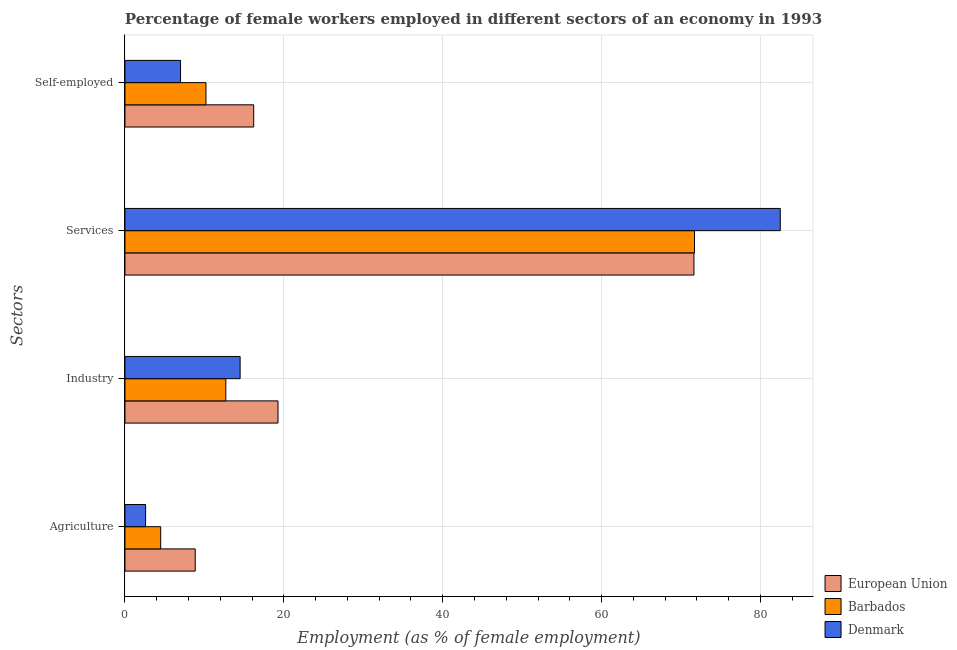Are the number of bars on each tick of the Y-axis equal?
Offer a terse response. Yes. How many bars are there on the 1st tick from the bottom?
Give a very brief answer. 3. What is the label of the 3rd group of bars from the top?
Offer a terse response. Industry. What is the percentage of female workers in agriculture in Denmark?
Provide a short and direct response. 2.6. Across all countries, what is the maximum percentage of self employed female workers?
Offer a terse response. 16.21. Across all countries, what is the minimum percentage of female workers in agriculture?
Offer a very short reply. 2.6. In which country was the percentage of female workers in industry minimum?
Keep it short and to the point. Barbados. What is the total percentage of female workers in services in the graph?
Ensure brevity in your answer.  225.83. What is the difference between the percentage of self employed female workers in Barbados and that in Denmark?
Your answer should be very brief. 3.2. What is the difference between the percentage of female workers in agriculture in Barbados and the percentage of self employed female workers in European Union?
Give a very brief answer. -11.71. What is the average percentage of self employed female workers per country?
Ensure brevity in your answer.  11.14. In how many countries, is the percentage of self employed female workers greater than 12 %?
Offer a very short reply. 1. What is the ratio of the percentage of female workers in agriculture in European Union to that in Barbados?
Give a very brief answer. 1.97. Is the percentage of self employed female workers in European Union less than that in Denmark?
Offer a terse response. No. Is the difference between the percentage of female workers in industry in Barbados and Denmark greater than the difference between the percentage of self employed female workers in Barbados and Denmark?
Your answer should be very brief. No. What is the difference between the highest and the second highest percentage of female workers in industry?
Make the answer very short. 4.77. What is the difference between the highest and the lowest percentage of female workers in agriculture?
Offer a terse response. 6.25. Is the sum of the percentage of female workers in agriculture in Denmark and Barbados greater than the maximum percentage of female workers in industry across all countries?
Provide a succinct answer. No. Is it the case that in every country, the sum of the percentage of self employed female workers and percentage of female workers in agriculture is greater than the sum of percentage of female workers in services and percentage of female workers in industry?
Provide a short and direct response. No. What does the 2nd bar from the bottom in Self-employed represents?
Your answer should be very brief. Barbados. How many countries are there in the graph?
Give a very brief answer. 3. Are the values on the major ticks of X-axis written in scientific E-notation?
Keep it short and to the point. No. Does the graph contain grids?
Your response must be concise. Yes. Where does the legend appear in the graph?
Your answer should be compact. Bottom right. How many legend labels are there?
Your answer should be very brief. 3. How are the legend labels stacked?
Your answer should be compact. Vertical. What is the title of the graph?
Make the answer very short. Percentage of female workers employed in different sectors of an economy in 1993. Does "Netherlands" appear as one of the legend labels in the graph?
Keep it short and to the point. No. What is the label or title of the X-axis?
Keep it short and to the point. Employment (as % of female employment). What is the label or title of the Y-axis?
Give a very brief answer. Sectors. What is the Employment (as % of female employment) in European Union in Agriculture?
Your answer should be compact. 8.85. What is the Employment (as % of female employment) in Denmark in Agriculture?
Keep it short and to the point. 2.6. What is the Employment (as % of female employment) of European Union in Industry?
Your response must be concise. 19.27. What is the Employment (as % of female employment) in Barbados in Industry?
Make the answer very short. 12.7. What is the Employment (as % of female employment) in Denmark in Industry?
Ensure brevity in your answer.  14.5. What is the Employment (as % of female employment) in European Union in Services?
Provide a succinct answer. 71.63. What is the Employment (as % of female employment) in Barbados in Services?
Give a very brief answer. 71.7. What is the Employment (as % of female employment) in Denmark in Services?
Your answer should be compact. 82.5. What is the Employment (as % of female employment) of European Union in Self-employed?
Your answer should be compact. 16.21. What is the Employment (as % of female employment) in Barbados in Self-employed?
Provide a short and direct response. 10.2. Across all Sectors, what is the maximum Employment (as % of female employment) of European Union?
Keep it short and to the point. 71.63. Across all Sectors, what is the maximum Employment (as % of female employment) of Barbados?
Your answer should be very brief. 71.7. Across all Sectors, what is the maximum Employment (as % of female employment) of Denmark?
Give a very brief answer. 82.5. Across all Sectors, what is the minimum Employment (as % of female employment) in European Union?
Your answer should be very brief. 8.85. Across all Sectors, what is the minimum Employment (as % of female employment) of Barbados?
Provide a short and direct response. 4.5. Across all Sectors, what is the minimum Employment (as % of female employment) of Denmark?
Offer a very short reply. 2.6. What is the total Employment (as % of female employment) in European Union in the graph?
Offer a terse response. 115.96. What is the total Employment (as % of female employment) of Barbados in the graph?
Provide a succinct answer. 99.1. What is the total Employment (as % of female employment) in Denmark in the graph?
Offer a very short reply. 106.6. What is the difference between the Employment (as % of female employment) of European Union in Agriculture and that in Industry?
Ensure brevity in your answer.  -10.42. What is the difference between the Employment (as % of female employment) of Denmark in Agriculture and that in Industry?
Provide a short and direct response. -11.9. What is the difference between the Employment (as % of female employment) in European Union in Agriculture and that in Services?
Make the answer very short. -62.78. What is the difference between the Employment (as % of female employment) in Barbados in Agriculture and that in Services?
Your response must be concise. -67.2. What is the difference between the Employment (as % of female employment) in Denmark in Agriculture and that in Services?
Make the answer very short. -79.9. What is the difference between the Employment (as % of female employment) of European Union in Agriculture and that in Self-employed?
Ensure brevity in your answer.  -7.36. What is the difference between the Employment (as % of female employment) in Barbados in Agriculture and that in Self-employed?
Offer a very short reply. -5.7. What is the difference between the Employment (as % of female employment) in European Union in Industry and that in Services?
Keep it short and to the point. -52.36. What is the difference between the Employment (as % of female employment) of Barbados in Industry and that in Services?
Your answer should be compact. -59. What is the difference between the Employment (as % of female employment) of Denmark in Industry and that in Services?
Provide a short and direct response. -68. What is the difference between the Employment (as % of female employment) of European Union in Industry and that in Self-employed?
Offer a terse response. 3.06. What is the difference between the Employment (as % of female employment) in Denmark in Industry and that in Self-employed?
Provide a short and direct response. 7.5. What is the difference between the Employment (as % of female employment) in European Union in Services and that in Self-employed?
Your response must be concise. 55.42. What is the difference between the Employment (as % of female employment) of Barbados in Services and that in Self-employed?
Keep it short and to the point. 61.5. What is the difference between the Employment (as % of female employment) in Denmark in Services and that in Self-employed?
Your answer should be compact. 75.5. What is the difference between the Employment (as % of female employment) of European Union in Agriculture and the Employment (as % of female employment) of Barbados in Industry?
Your response must be concise. -3.85. What is the difference between the Employment (as % of female employment) in European Union in Agriculture and the Employment (as % of female employment) in Denmark in Industry?
Offer a very short reply. -5.65. What is the difference between the Employment (as % of female employment) of European Union in Agriculture and the Employment (as % of female employment) of Barbados in Services?
Make the answer very short. -62.85. What is the difference between the Employment (as % of female employment) in European Union in Agriculture and the Employment (as % of female employment) in Denmark in Services?
Your answer should be compact. -73.65. What is the difference between the Employment (as % of female employment) in Barbados in Agriculture and the Employment (as % of female employment) in Denmark in Services?
Ensure brevity in your answer.  -78. What is the difference between the Employment (as % of female employment) in European Union in Agriculture and the Employment (as % of female employment) in Barbados in Self-employed?
Make the answer very short. -1.35. What is the difference between the Employment (as % of female employment) in European Union in Agriculture and the Employment (as % of female employment) in Denmark in Self-employed?
Make the answer very short. 1.85. What is the difference between the Employment (as % of female employment) of European Union in Industry and the Employment (as % of female employment) of Barbados in Services?
Make the answer very short. -52.43. What is the difference between the Employment (as % of female employment) of European Union in Industry and the Employment (as % of female employment) of Denmark in Services?
Give a very brief answer. -63.23. What is the difference between the Employment (as % of female employment) of Barbados in Industry and the Employment (as % of female employment) of Denmark in Services?
Keep it short and to the point. -69.8. What is the difference between the Employment (as % of female employment) of European Union in Industry and the Employment (as % of female employment) of Barbados in Self-employed?
Make the answer very short. 9.07. What is the difference between the Employment (as % of female employment) in European Union in Industry and the Employment (as % of female employment) in Denmark in Self-employed?
Ensure brevity in your answer.  12.27. What is the difference between the Employment (as % of female employment) of European Union in Services and the Employment (as % of female employment) of Barbados in Self-employed?
Your answer should be very brief. 61.43. What is the difference between the Employment (as % of female employment) in European Union in Services and the Employment (as % of female employment) in Denmark in Self-employed?
Offer a very short reply. 64.63. What is the difference between the Employment (as % of female employment) in Barbados in Services and the Employment (as % of female employment) in Denmark in Self-employed?
Offer a terse response. 64.7. What is the average Employment (as % of female employment) of European Union per Sectors?
Your response must be concise. 28.99. What is the average Employment (as % of female employment) in Barbados per Sectors?
Provide a succinct answer. 24.77. What is the average Employment (as % of female employment) in Denmark per Sectors?
Make the answer very short. 26.65. What is the difference between the Employment (as % of female employment) in European Union and Employment (as % of female employment) in Barbados in Agriculture?
Your response must be concise. 4.35. What is the difference between the Employment (as % of female employment) in European Union and Employment (as % of female employment) in Denmark in Agriculture?
Offer a very short reply. 6.25. What is the difference between the Employment (as % of female employment) of European Union and Employment (as % of female employment) of Barbados in Industry?
Give a very brief answer. 6.57. What is the difference between the Employment (as % of female employment) in European Union and Employment (as % of female employment) in Denmark in Industry?
Ensure brevity in your answer.  4.77. What is the difference between the Employment (as % of female employment) of Barbados and Employment (as % of female employment) of Denmark in Industry?
Give a very brief answer. -1.8. What is the difference between the Employment (as % of female employment) in European Union and Employment (as % of female employment) in Barbados in Services?
Your response must be concise. -0.07. What is the difference between the Employment (as % of female employment) in European Union and Employment (as % of female employment) in Denmark in Services?
Your answer should be compact. -10.87. What is the difference between the Employment (as % of female employment) in Barbados and Employment (as % of female employment) in Denmark in Services?
Your answer should be compact. -10.8. What is the difference between the Employment (as % of female employment) of European Union and Employment (as % of female employment) of Barbados in Self-employed?
Your answer should be compact. 6.01. What is the difference between the Employment (as % of female employment) of European Union and Employment (as % of female employment) of Denmark in Self-employed?
Your answer should be very brief. 9.21. What is the difference between the Employment (as % of female employment) in Barbados and Employment (as % of female employment) in Denmark in Self-employed?
Offer a terse response. 3.2. What is the ratio of the Employment (as % of female employment) in European Union in Agriculture to that in Industry?
Your answer should be compact. 0.46. What is the ratio of the Employment (as % of female employment) in Barbados in Agriculture to that in Industry?
Provide a short and direct response. 0.35. What is the ratio of the Employment (as % of female employment) of Denmark in Agriculture to that in Industry?
Offer a very short reply. 0.18. What is the ratio of the Employment (as % of female employment) in European Union in Agriculture to that in Services?
Offer a very short reply. 0.12. What is the ratio of the Employment (as % of female employment) of Barbados in Agriculture to that in Services?
Offer a very short reply. 0.06. What is the ratio of the Employment (as % of female employment) in Denmark in Agriculture to that in Services?
Your answer should be compact. 0.03. What is the ratio of the Employment (as % of female employment) of European Union in Agriculture to that in Self-employed?
Offer a very short reply. 0.55. What is the ratio of the Employment (as % of female employment) of Barbados in Agriculture to that in Self-employed?
Make the answer very short. 0.44. What is the ratio of the Employment (as % of female employment) in Denmark in Agriculture to that in Self-employed?
Your answer should be very brief. 0.37. What is the ratio of the Employment (as % of female employment) in European Union in Industry to that in Services?
Keep it short and to the point. 0.27. What is the ratio of the Employment (as % of female employment) of Barbados in Industry to that in Services?
Your answer should be compact. 0.18. What is the ratio of the Employment (as % of female employment) of Denmark in Industry to that in Services?
Keep it short and to the point. 0.18. What is the ratio of the Employment (as % of female employment) in European Union in Industry to that in Self-employed?
Provide a succinct answer. 1.19. What is the ratio of the Employment (as % of female employment) of Barbados in Industry to that in Self-employed?
Keep it short and to the point. 1.25. What is the ratio of the Employment (as % of female employment) of Denmark in Industry to that in Self-employed?
Provide a succinct answer. 2.07. What is the ratio of the Employment (as % of female employment) of European Union in Services to that in Self-employed?
Keep it short and to the point. 4.42. What is the ratio of the Employment (as % of female employment) in Barbados in Services to that in Self-employed?
Your answer should be very brief. 7.03. What is the ratio of the Employment (as % of female employment) of Denmark in Services to that in Self-employed?
Offer a terse response. 11.79. What is the difference between the highest and the second highest Employment (as % of female employment) in European Union?
Your response must be concise. 52.36. What is the difference between the highest and the second highest Employment (as % of female employment) in Denmark?
Keep it short and to the point. 68. What is the difference between the highest and the lowest Employment (as % of female employment) in European Union?
Your answer should be compact. 62.78. What is the difference between the highest and the lowest Employment (as % of female employment) of Barbados?
Your response must be concise. 67.2. What is the difference between the highest and the lowest Employment (as % of female employment) of Denmark?
Make the answer very short. 79.9. 